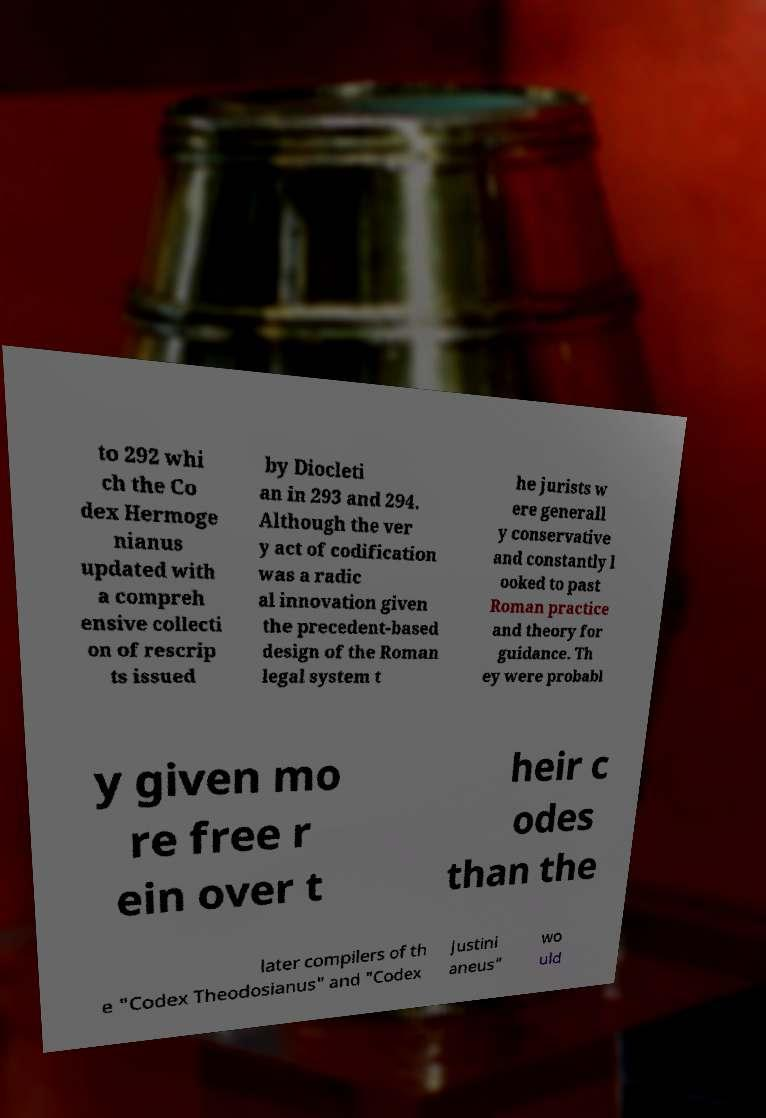For documentation purposes, I need the text within this image transcribed. Could you provide that? to 292 whi ch the Co dex Hermoge nianus updated with a compreh ensive collecti on of rescrip ts issued by Diocleti an in 293 and 294. Although the ver y act of codification was a radic al innovation given the precedent-based design of the Roman legal system t he jurists w ere generall y conservative and constantly l ooked to past Roman practice and theory for guidance. Th ey were probabl y given mo re free r ein over t heir c odes than the later compilers of th e "Codex Theodosianus" and "Codex Justini aneus" wo uld 